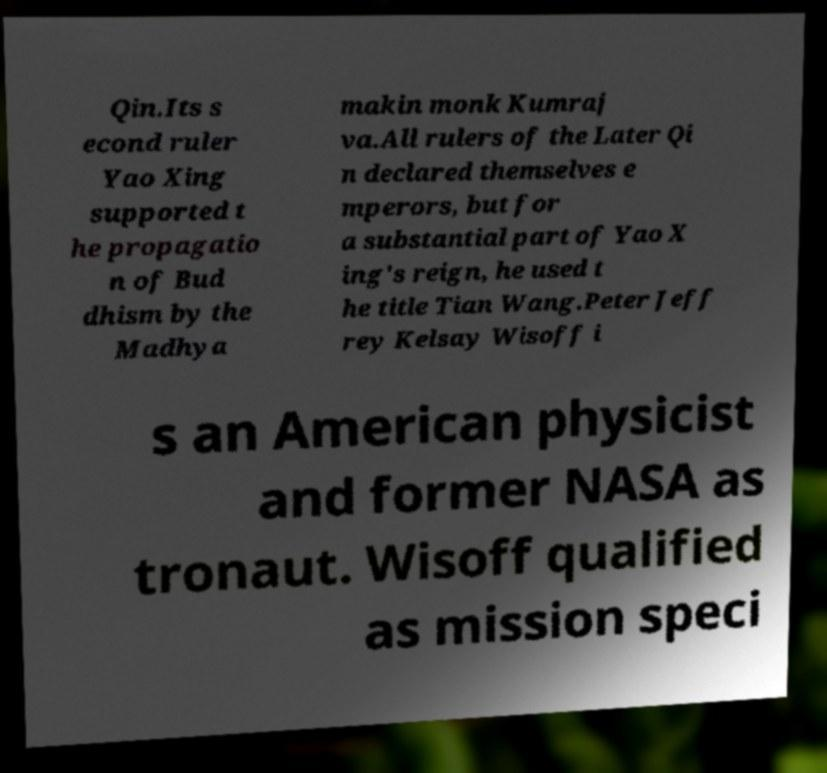Please identify and transcribe the text found in this image. Qin.Its s econd ruler Yao Xing supported t he propagatio n of Bud dhism by the Madhya makin monk Kumraj va.All rulers of the Later Qi n declared themselves e mperors, but for a substantial part of Yao X ing's reign, he used t he title Tian Wang.Peter Jeff rey Kelsay Wisoff i s an American physicist and former NASA as tronaut. Wisoff qualified as mission speci 